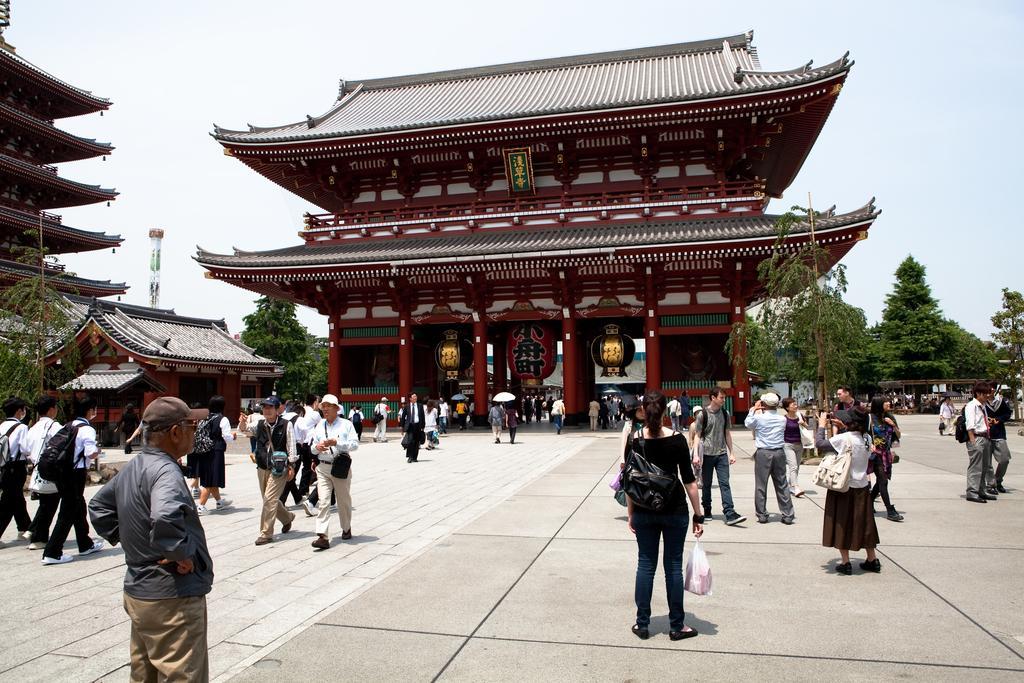Please provide a concise description of this image. In this picture there are group of people, few people are standing and few people are walking. At the back there are buildings and trees and there is a tower. At the top there is sky. At the bottom there is a road. 